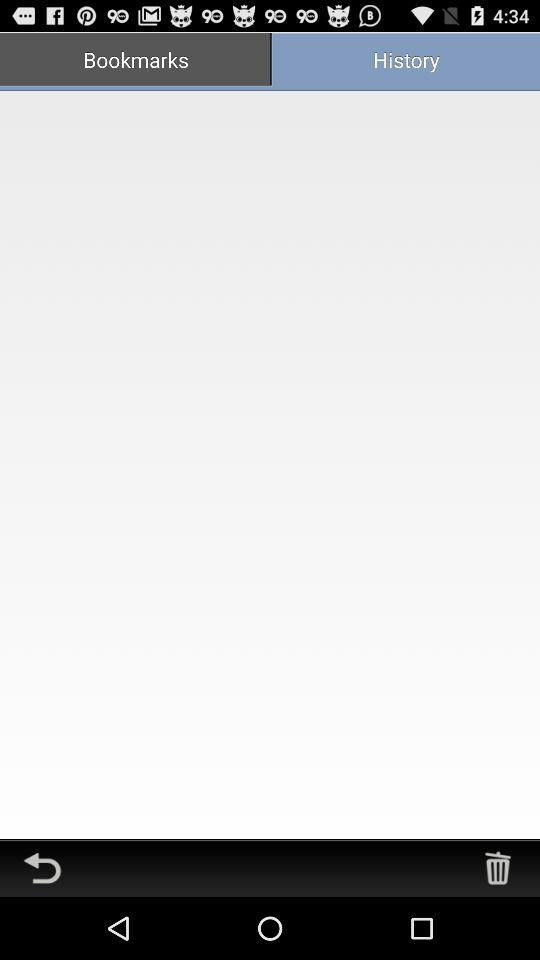Which tab is selected? The selected tab is "Bookmarks". 